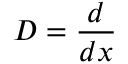Convert formula to latex. <formula><loc_0><loc_0><loc_500><loc_500>D = { \frac { d } { d x } }</formula> 